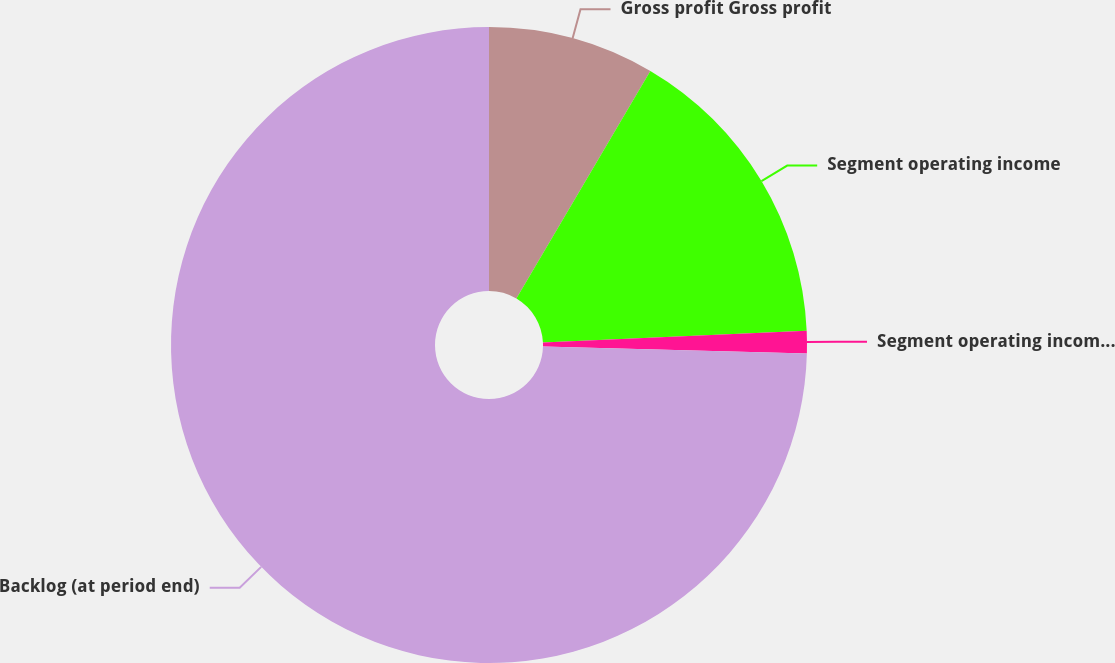Convert chart to OTSL. <chart><loc_0><loc_0><loc_500><loc_500><pie_chart><fcel>Gross profit Gross profit<fcel>Segment operating income<fcel>Segment operating income as a<fcel>Backlog (at period end)<nl><fcel>8.47%<fcel>15.82%<fcel>1.13%<fcel>74.58%<nl></chart> 